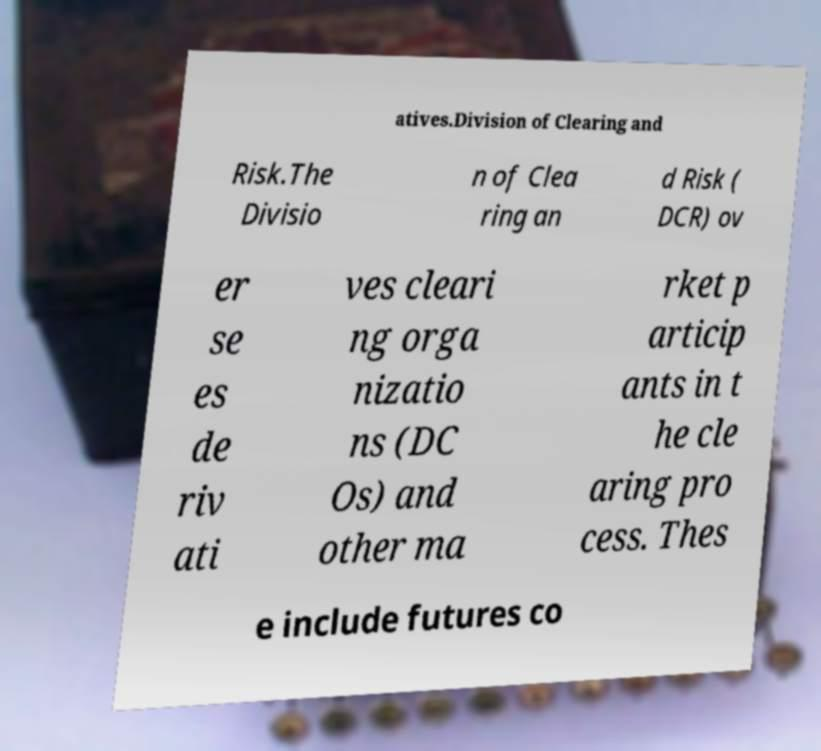Could you assist in decoding the text presented in this image and type it out clearly? atives.Division of Clearing and Risk.The Divisio n of Clea ring an d Risk ( DCR) ov er se es de riv ati ves cleari ng orga nizatio ns (DC Os) and other ma rket p articip ants in t he cle aring pro cess. Thes e include futures co 